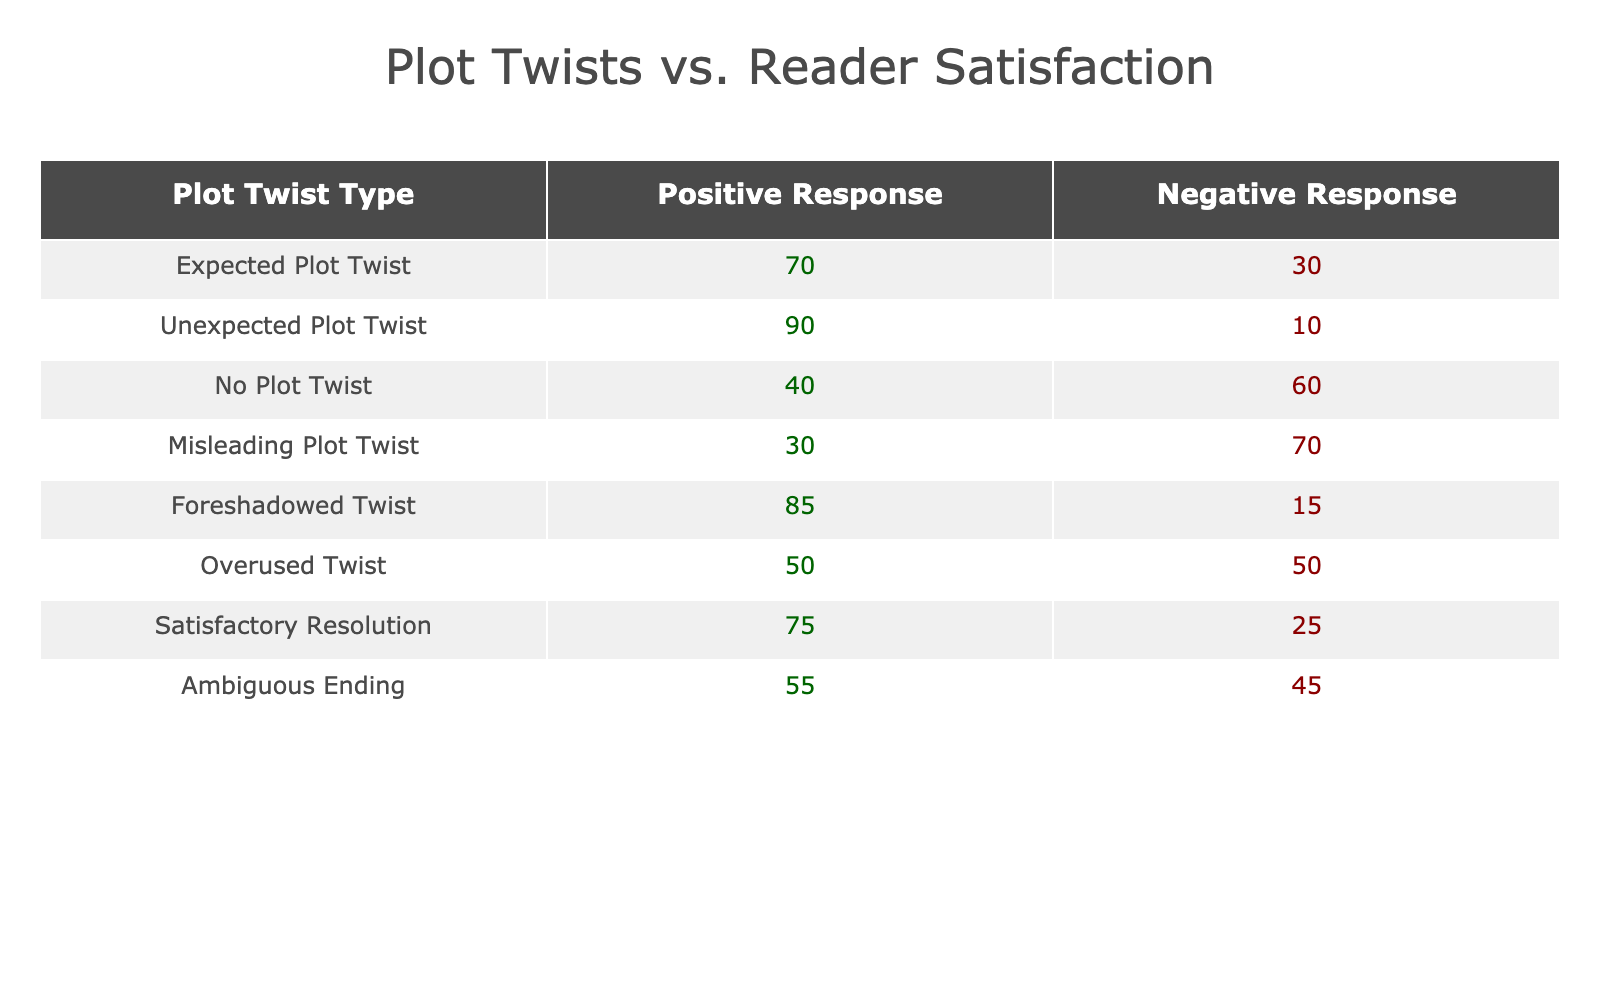What is the positive response percentage for the "Unexpected Plot Twist"? By referring to the table, "Unexpected Plot Twist" has 90 listed under the "Positive Response" column. Therefore, the positive response percentage is 90%.
Answer: 90% Which plot twist yields the highest negative response? The highest negative response in the table is for "Misleading Plot Twist," where 70 responses are negative, which is greater than any other plot twist type.
Answer: Misleading Plot Twist What is the total positive response for all plot twists? To find the total positive responses, we add the positive responses of all types: 70 + 90 + 40 + 30 + 85 + 50 + 75 + 55 = 495.
Answer: 495 Is "Foreshadowed Twist" associated with a higher positive or negative response? The "Foreshadowed Twist" has a positive response of 85 and a negative response of 15. Since 85 is greater than 15, it is associated with a higher positive response.
Answer: Yes What is the average negative response across all plot twist categories? To find the average negative response, add all the negative responses: 30 + 10 + 60 + 70 + 15 + 50 + 25 + 45 = 310. There are 8 plot twist categories, so the average is 310 / 8 = 38.75.
Answer: 38.75 